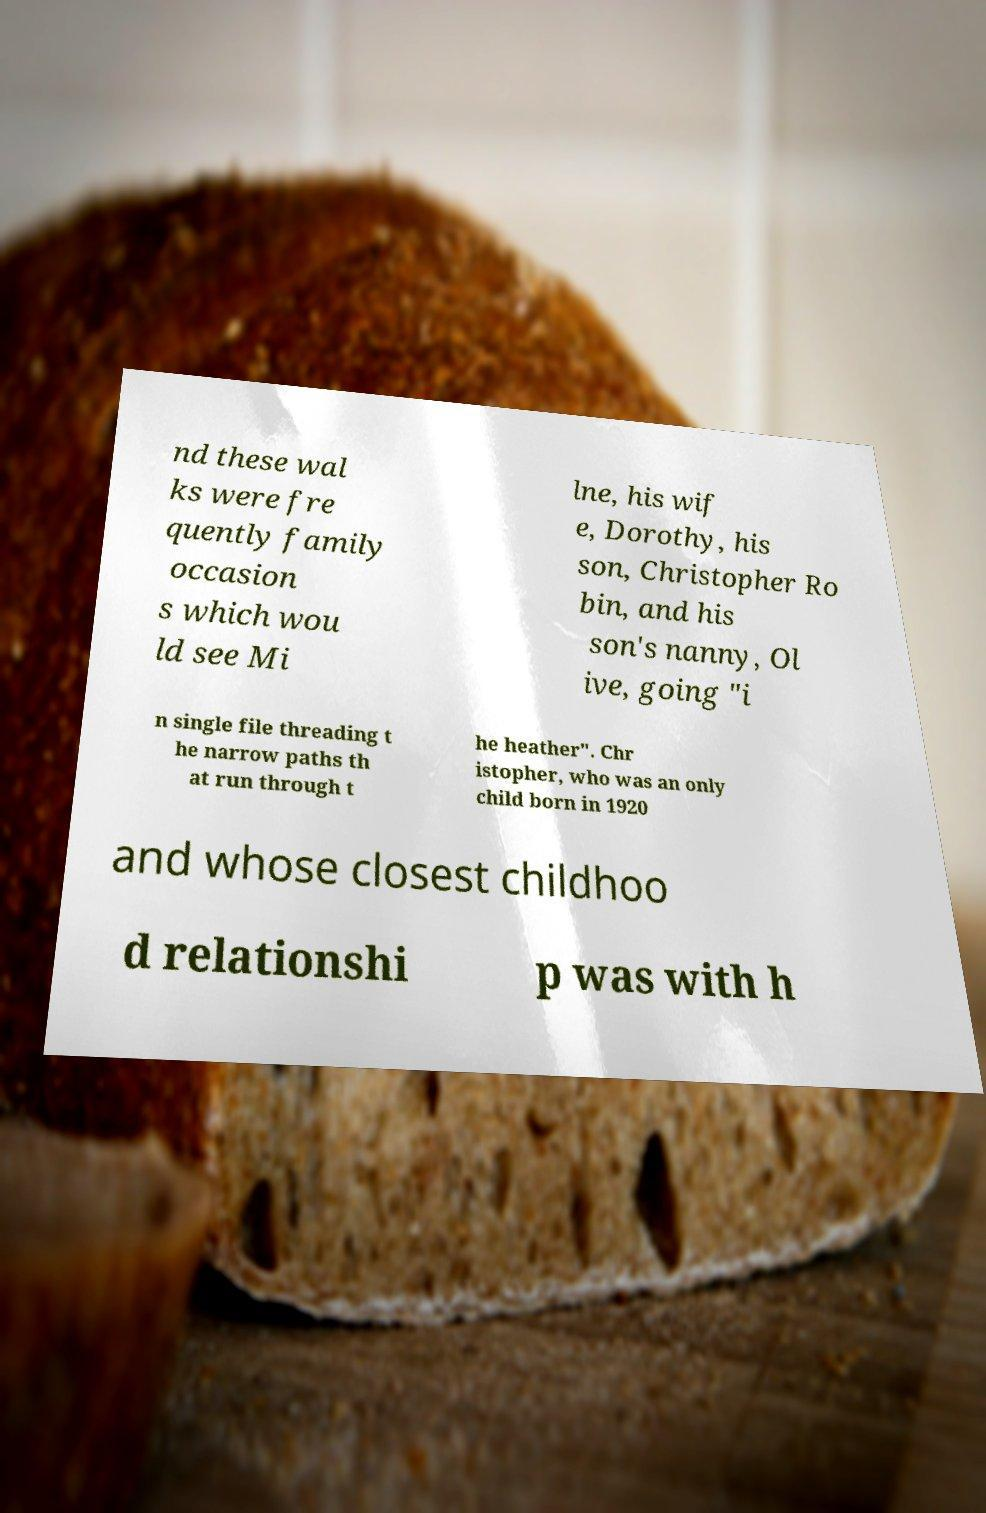Could you extract and type out the text from this image? nd these wal ks were fre quently family occasion s which wou ld see Mi lne, his wif e, Dorothy, his son, Christopher Ro bin, and his son's nanny, Ol ive, going "i n single file threading t he narrow paths th at run through t he heather". Chr istopher, who was an only child born in 1920 and whose closest childhoo d relationshi p was with h 